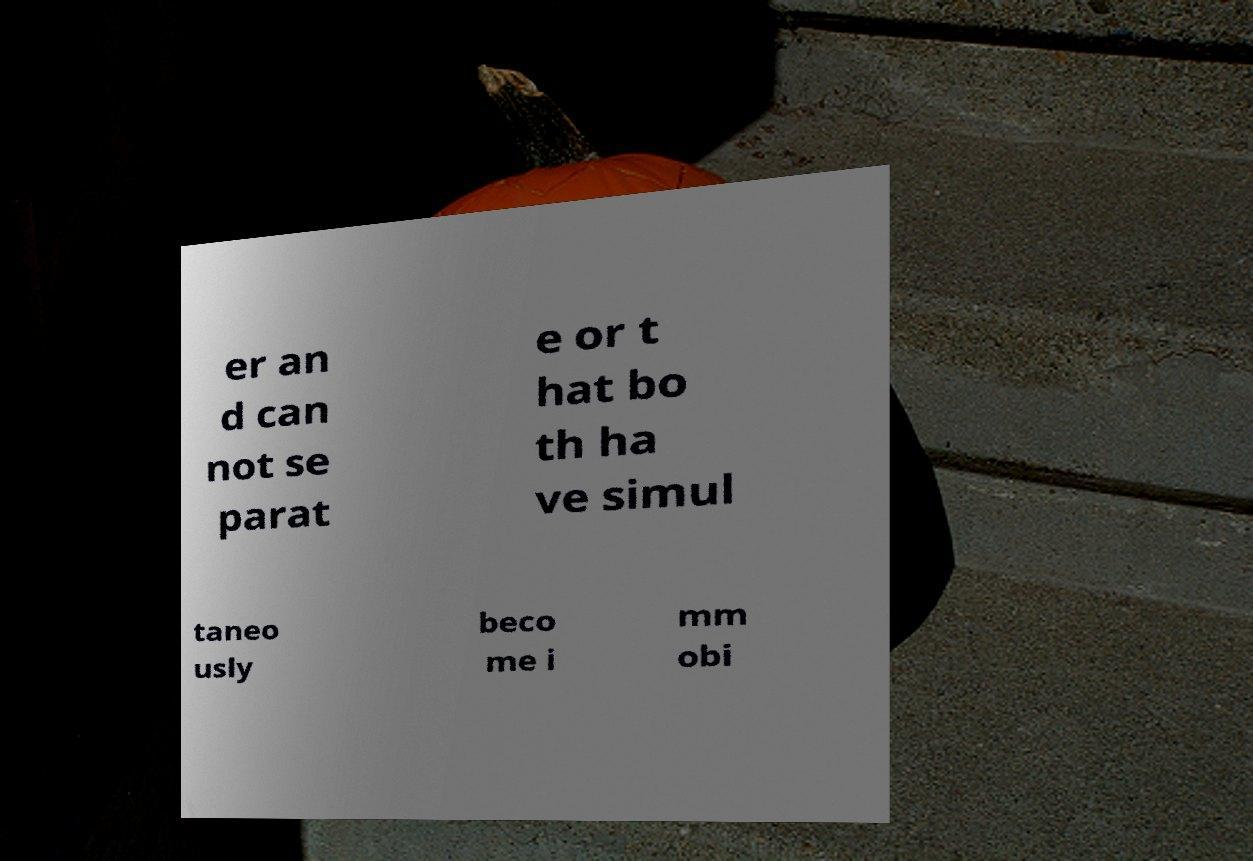Can you accurately transcribe the text from the provided image for me? er an d can not se parat e or t hat bo th ha ve simul taneo usly beco me i mm obi 